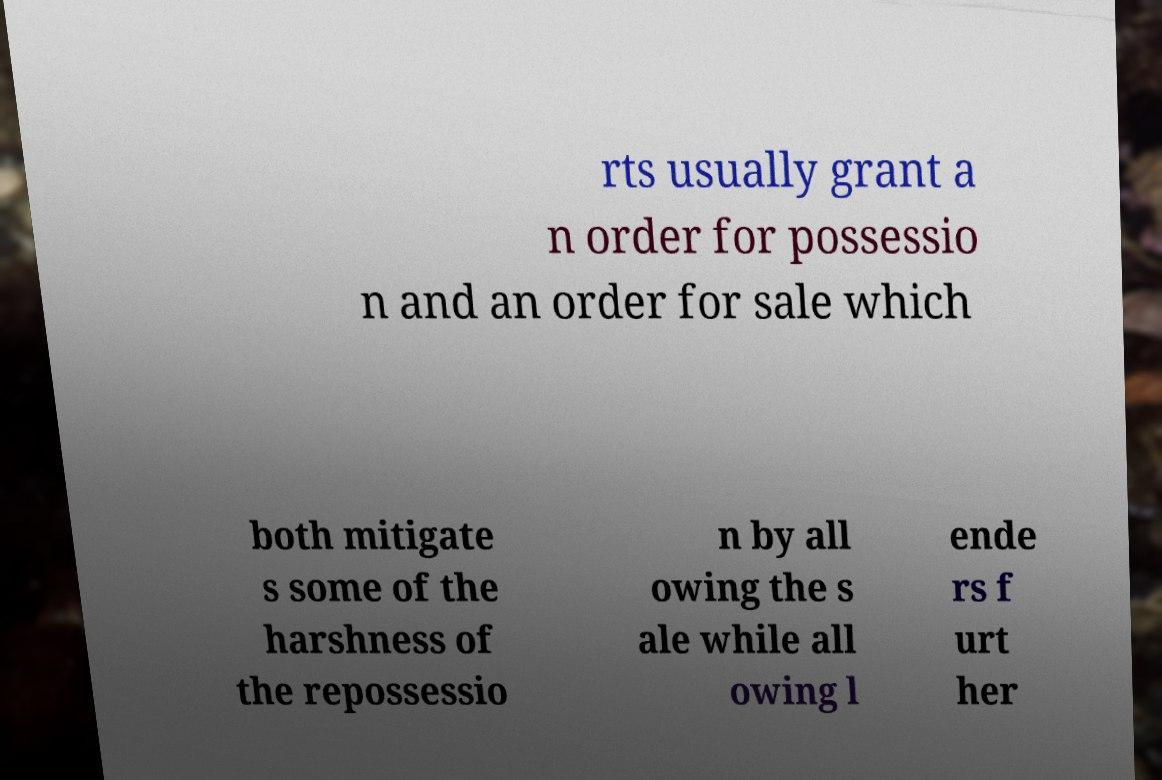Please identify and transcribe the text found in this image. rts usually grant a n order for possessio n and an order for sale which both mitigate s some of the harshness of the repossessio n by all owing the s ale while all owing l ende rs f urt her 